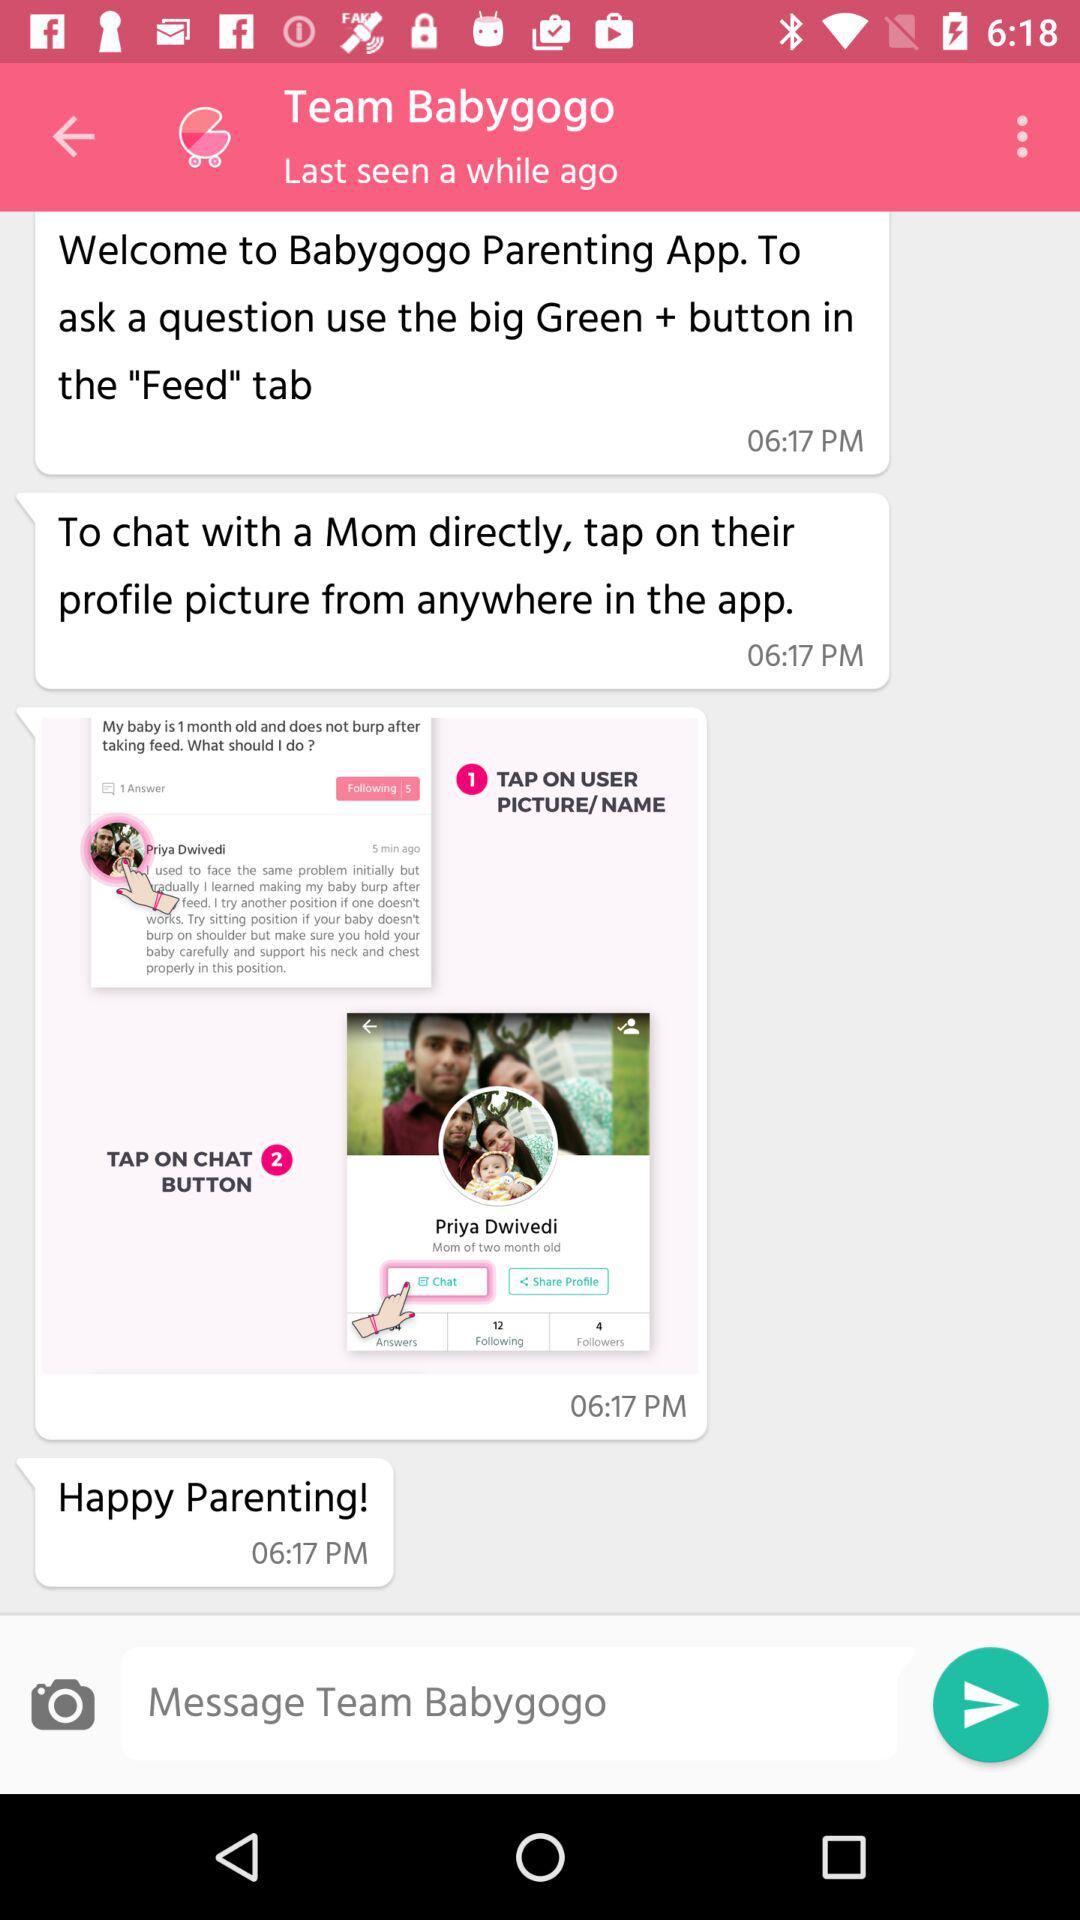How long ago was the user last seen? The user was last seen a while ago. 